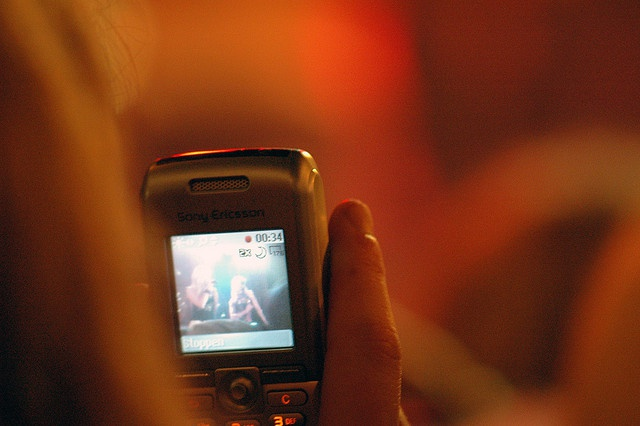Describe the objects in this image and their specific colors. I can see cell phone in maroon, black, lightgray, and darkgray tones and people in maroon, black, and brown tones in this image. 